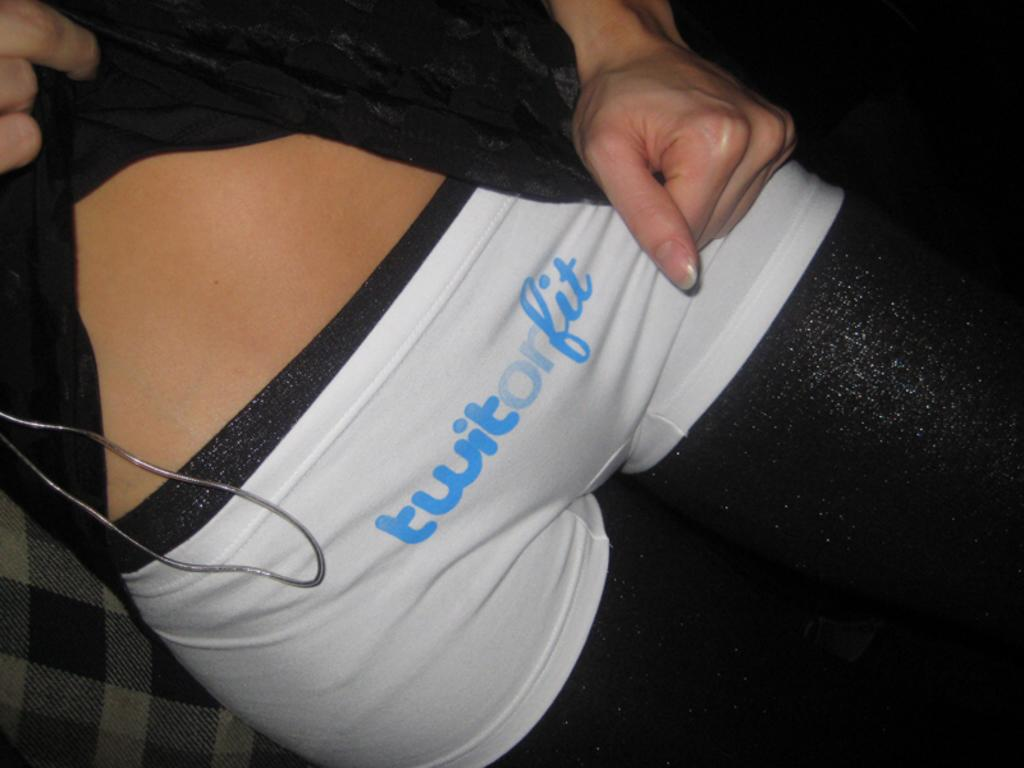<image>
Write a terse but informative summary of the picture. A close up of white shorts on a person that says Twitorfit on them. 